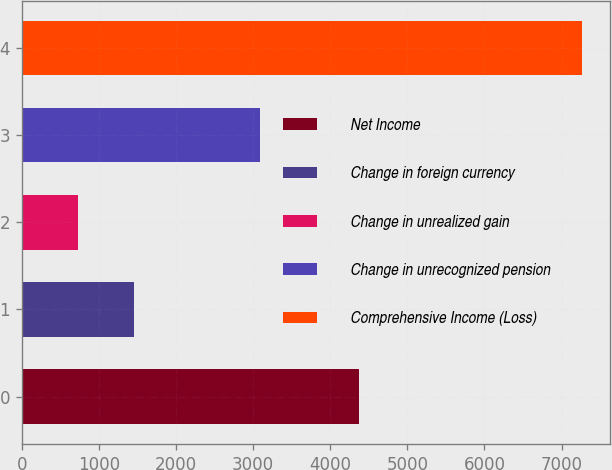<chart> <loc_0><loc_0><loc_500><loc_500><bar_chart><fcel>Net Income<fcel>Change in foreign currency<fcel>Change in unrealized gain<fcel>Change in unrecognized pension<fcel>Comprehensive Income (Loss)<nl><fcel>4372<fcel>1458.8<fcel>732.9<fcel>3094<fcel>7266<nl></chart> 